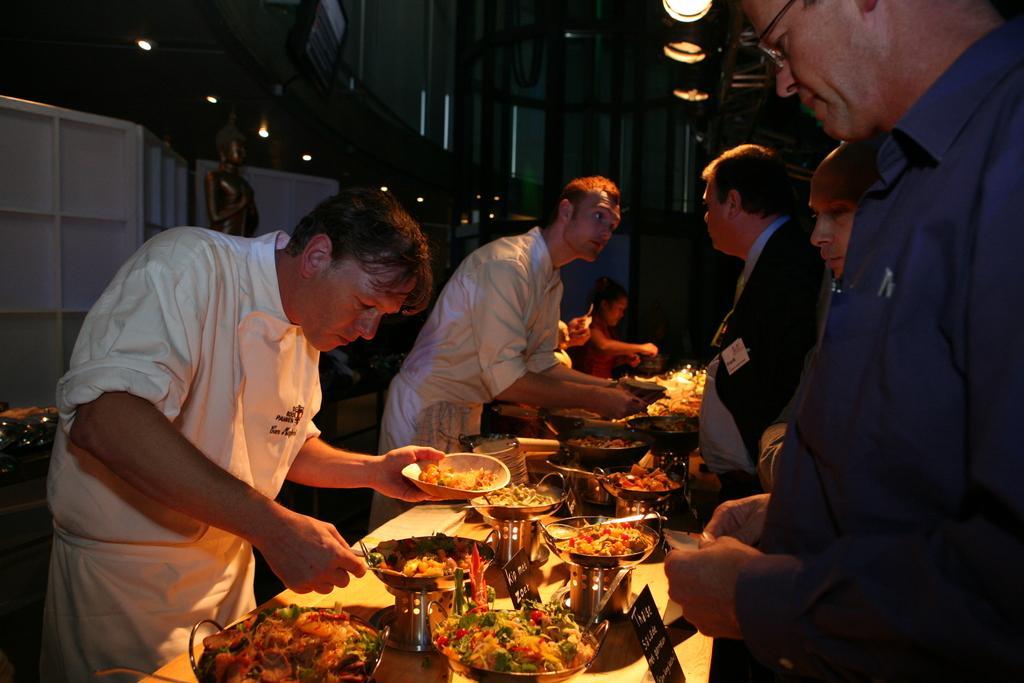Please provide a concise description of this image. As we can see in the image there are few people here and there, wall, lights and tables. On tables there are bowls and food items. 